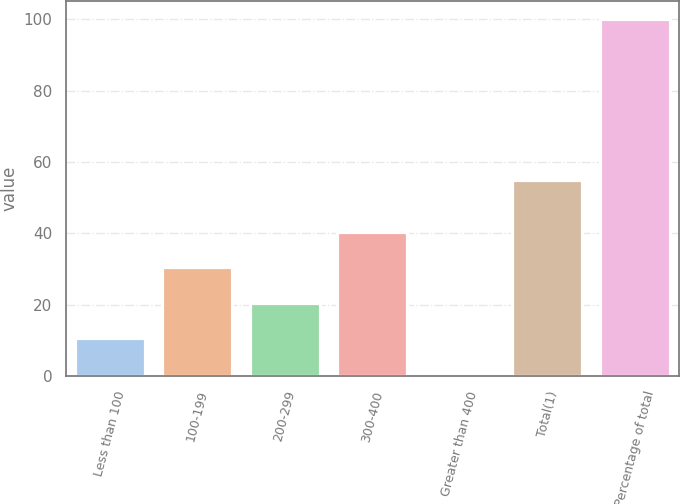Convert chart. <chart><loc_0><loc_0><loc_500><loc_500><bar_chart><fcel>Less than 100<fcel>100-199<fcel>200-299<fcel>300-400<fcel>Greater than 400<fcel>Total(1)<fcel>Percentage of total<nl><fcel>10.72<fcel>30.56<fcel>20.64<fcel>40.48<fcel>0.8<fcel>54.9<fcel>100<nl></chart> 